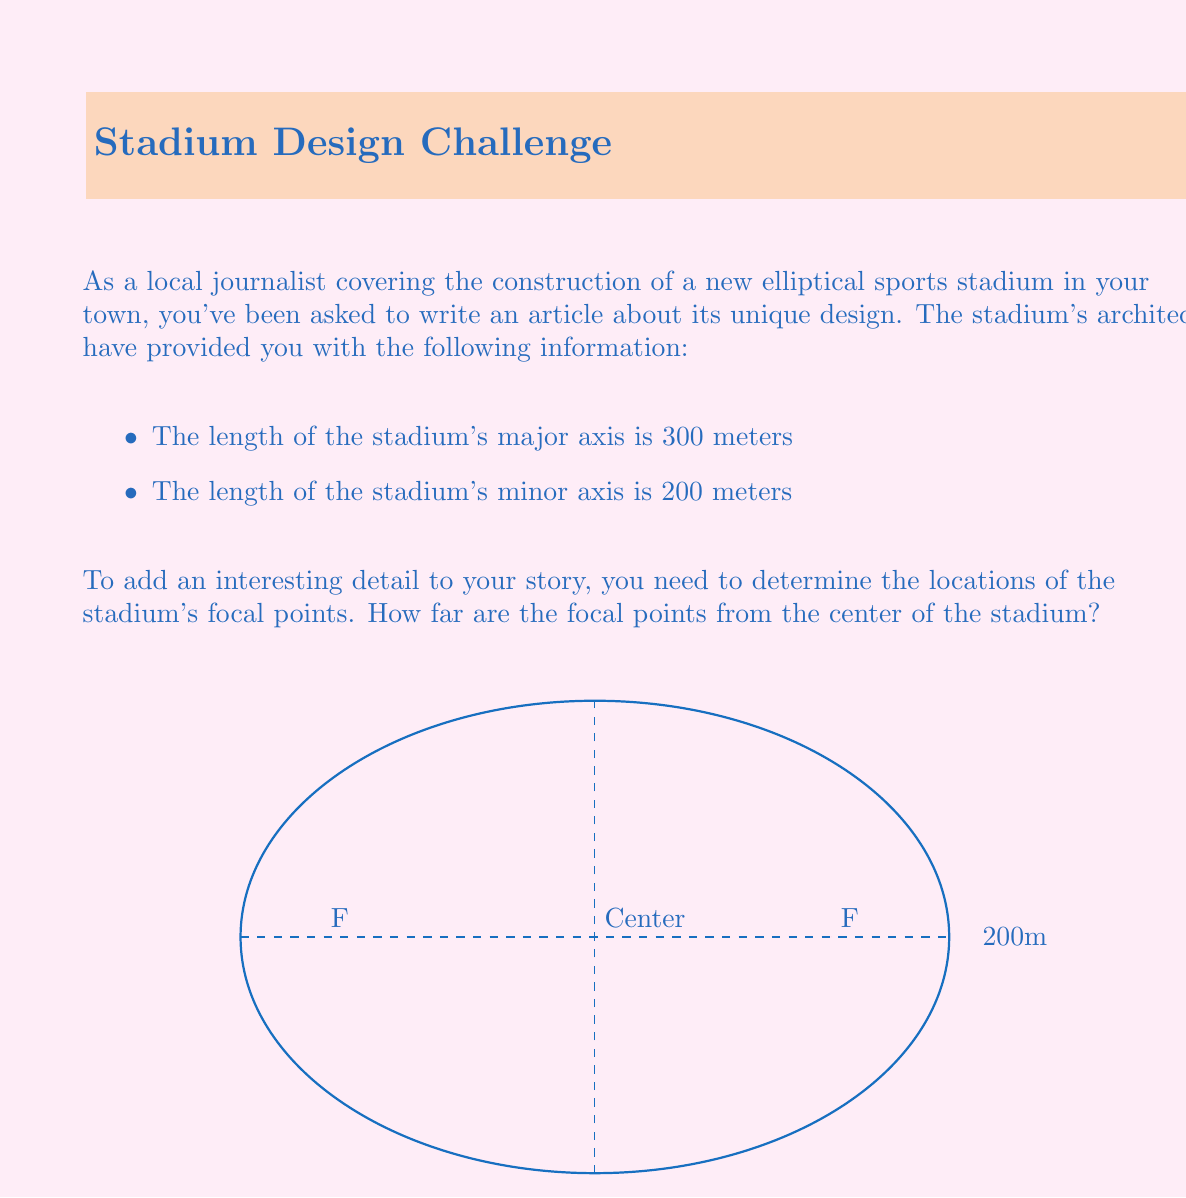Give your solution to this math problem. Let's approach this step-by-step:

1) In an ellipse, the relationship between the semi-major axis (a), semi-minor axis (b), and the distance from the center to a focal point (c) is given by the equation:

   $$a^2 = b^2 + c^2$$

2) We're given the full lengths of the axes, so let's calculate the semi-axes:
   
   Semi-major axis: $a = 300/2 = 150$ meters
   Semi-minor axis: $b = 200/2 = 100$ meters

3) Now, let's substitute these values into our equation:

   $$150^2 = 100^2 + c^2$$

4) Simplify:
   
   $$22500 = 10000 + c^2$$

5) Subtract 10000 from both sides:

   $$12500 = c^2$$

6) Take the square root of both sides:

   $$c = \sqrt{12500} = 50\sqrt{5} \approx 111.8$$ meters

Therefore, the focal points are approximately 111.8 meters from the center of the stadium.
Answer: $50\sqrt{5}$ meters or approximately 111.8 meters 